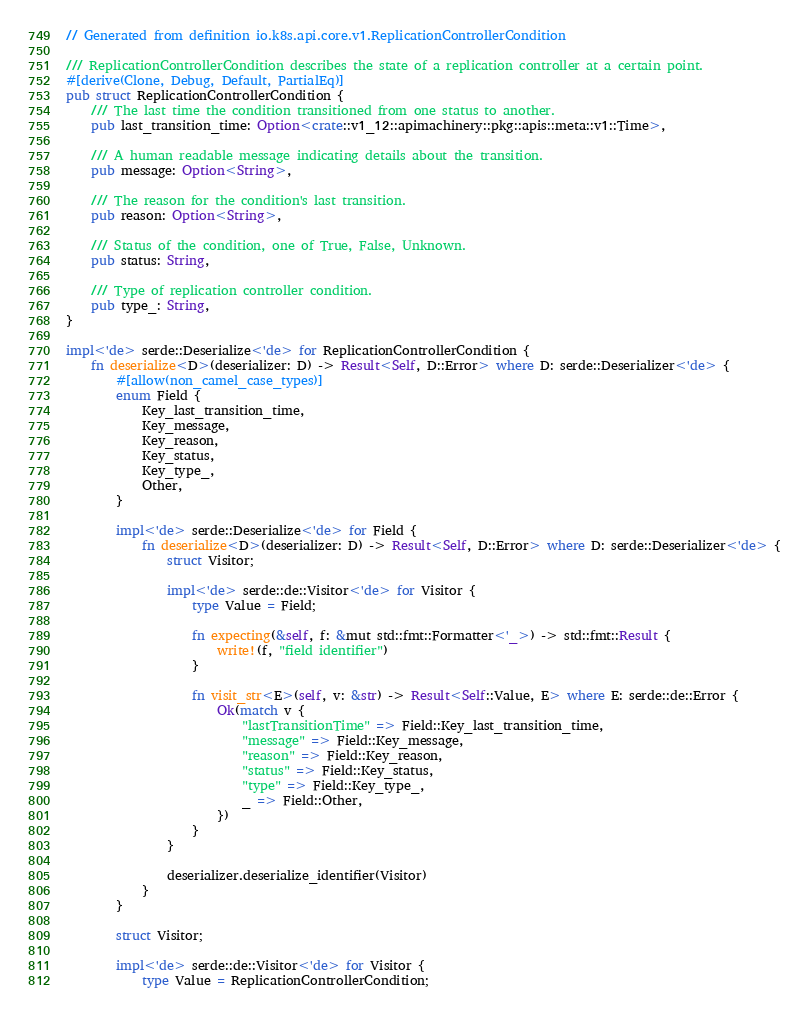<code> <loc_0><loc_0><loc_500><loc_500><_Rust_>// Generated from definition io.k8s.api.core.v1.ReplicationControllerCondition

/// ReplicationControllerCondition describes the state of a replication controller at a certain point.
#[derive(Clone, Debug, Default, PartialEq)]
pub struct ReplicationControllerCondition {
    /// The last time the condition transitioned from one status to another.
    pub last_transition_time: Option<crate::v1_12::apimachinery::pkg::apis::meta::v1::Time>,

    /// A human readable message indicating details about the transition.
    pub message: Option<String>,

    /// The reason for the condition's last transition.
    pub reason: Option<String>,

    /// Status of the condition, one of True, False, Unknown.
    pub status: String,

    /// Type of replication controller condition.
    pub type_: String,
}

impl<'de> serde::Deserialize<'de> for ReplicationControllerCondition {
    fn deserialize<D>(deserializer: D) -> Result<Self, D::Error> where D: serde::Deserializer<'de> {
        #[allow(non_camel_case_types)]
        enum Field {
            Key_last_transition_time,
            Key_message,
            Key_reason,
            Key_status,
            Key_type_,
            Other,
        }

        impl<'de> serde::Deserialize<'de> for Field {
            fn deserialize<D>(deserializer: D) -> Result<Self, D::Error> where D: serde::Deserializer<'de> {
                struct Visitor;

                impl<'de> serde::de::Visitor<'de> for Visitor {
                    type Value = Field;

                    fn expecting(&self, f: &mut std::fmt::Formatter<'_>) -> std::fmt::Result {
                        write!(f, "field identifier")
                    }

                    fn visit_str<E>(self, v: &str) -> Result<Self::Value, E> where E: serde::de::Error {
                        Ok(match v {
                            "lastTransitionTime" => Field::Key_last_transition_time,
                            "message" => Field::Key_message,
                            "reason" => Field::Key_reason,
                            "status" => Field::Key_status,
                            "type" => Field::Key_type_,
                            _ => Field::Other,
                        })
                    }
                }

                deserializer.deserialize_identifier(Visitor)
            }
        }

        struct Visitor;

        impl<'de> serde::de::Visitor<'de> for Visitor {
            type Value = ReplicationControllerCondition;
</code> 